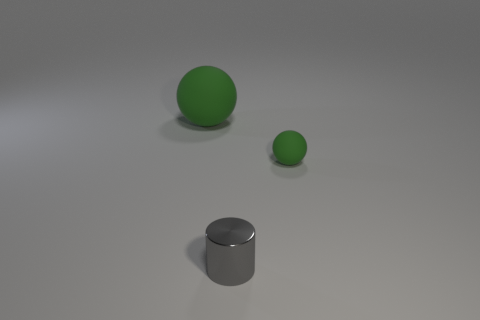Subtract all cylinders. How many objects are left? 2 Subtract all yellow cylinders. Subtract all gray balls. How many cylinders are left? 1 Subtract all metallic things. Subtract all small purple metal cubes. How many objects are left? 2 Add 1 green spheres. How many green spheres are left? 3 Add 3 large purple shiny cylinders. How many large purple shiny cylinders exist? 3 Add 1 small shiny cylinders. How many objects exist? 4 Subtract 0 purple cylinders. How many objects are left? 3 